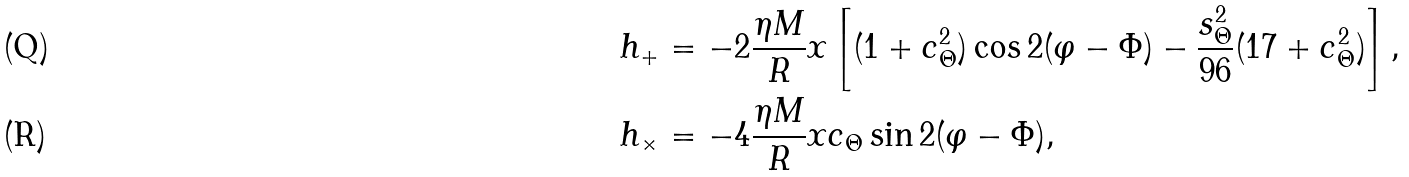Convert formula to latex. <formula><loc_0><loc_0><loc_500><loc_500>h _ { + } & = - 2 \frac { \eta M } { R } x \left [ ( 1 + c _ { \Theta } ^ { 2 } ) \cos 2 ( \varphi - \Phi ) - \frac { s ^ { 2 } _ { \Theta } } { 9 6 } ( 1 7 + c _ { \Theta } ^ { 2 } ) \right ] , \\ h _ { \times } & = - 4 \frac { \eta M } { R } x c _ { \Theta } \sin 2 ( \varphi - \Phi ) ,</formula> 